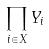<formula> <loc_0><loc_0><loc_500><loc_500>\prod _ { i \in X } Y _ { i }</formula> 